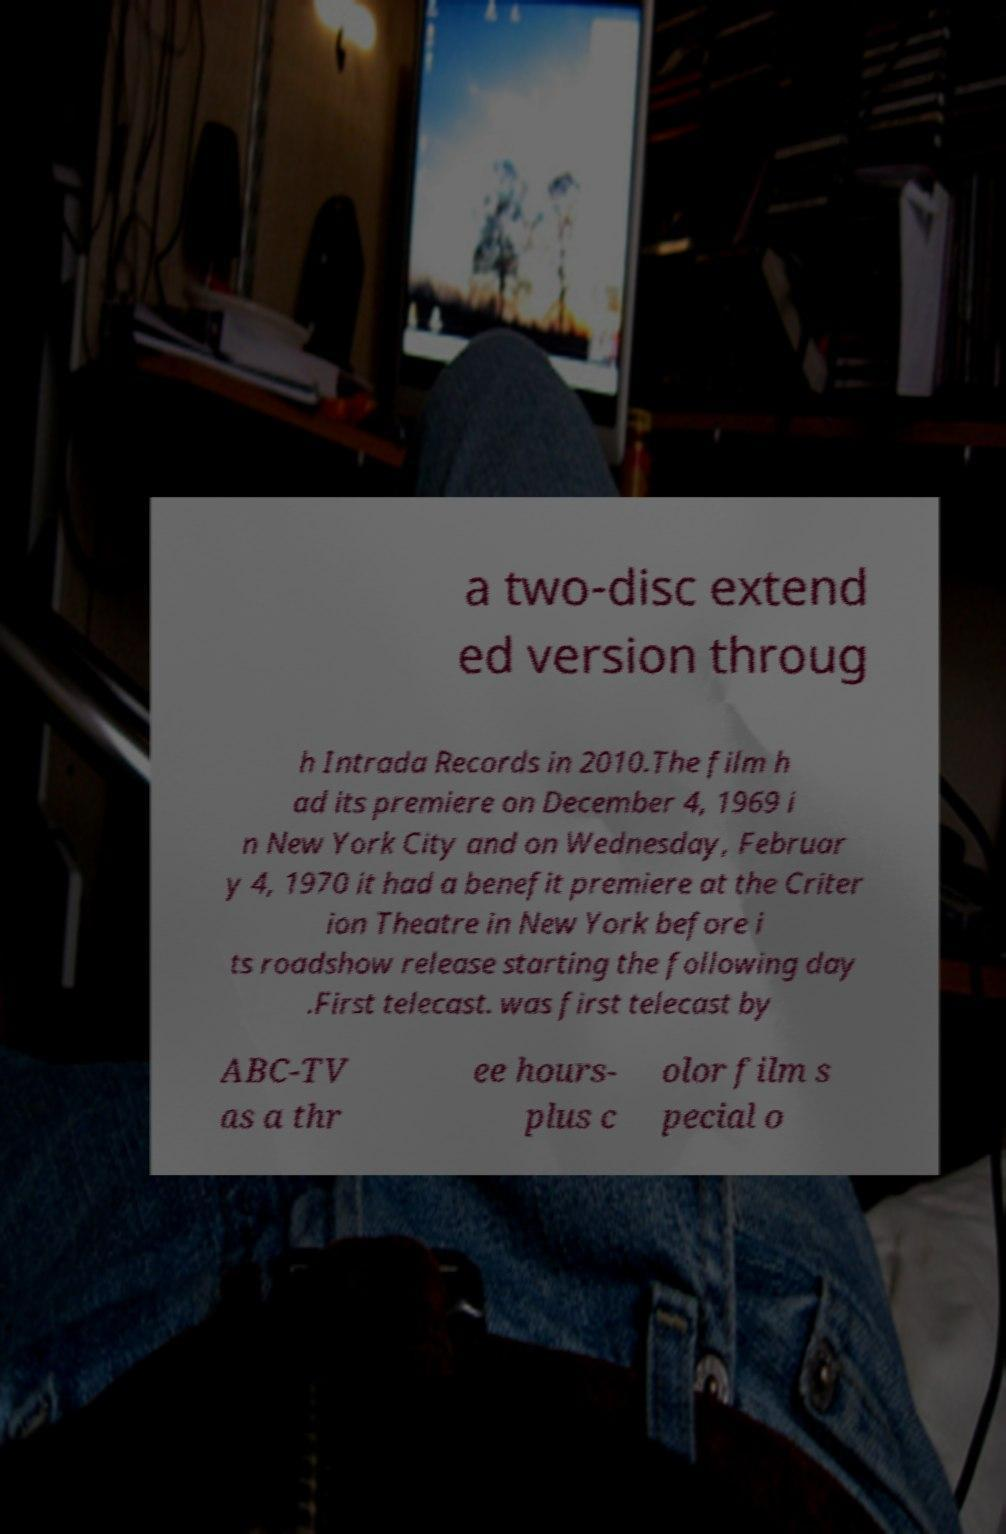Could you assist in decoding the text presented in this image and type it out clearly? a two-disc extend ed version throug h Intrada Records in 2010.The film h ad its premiere on December 4, 1969 i n New York City and on Wednesday, Februar y 4, 1970 it had a benefit premiere at the Criter ion Theatre in New York before i ts roadshow release starting the following day .First telecast. was first telecast by ABC-TV as a thr ee hours- plus c olor film s pecial o 